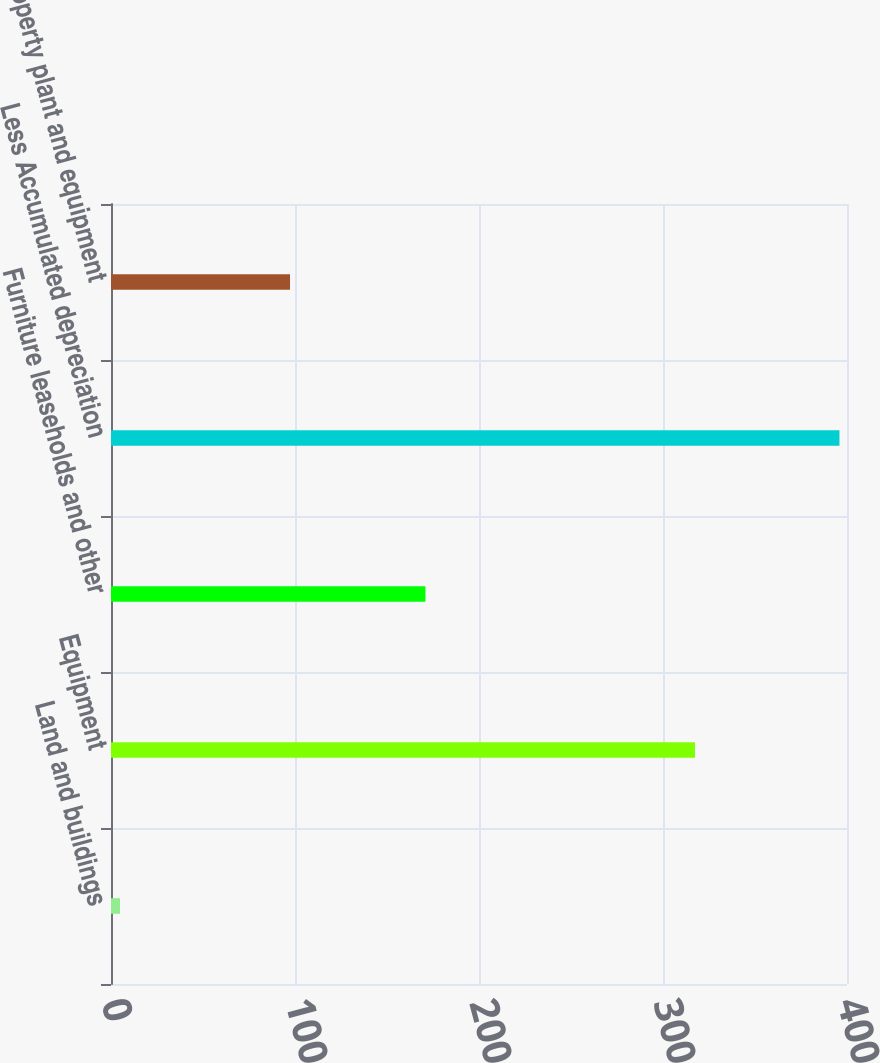Convert chart. <chart><loc_0><loc_0><loc_500><loc_500><bar_chart><fcel>Land and buildings<fcel>Equipment<fcel>Furniture leaseholds and other<fcel>Less Accumulated depreciation<fcel>Property plant and equipment<nl><fcel>4.9<fcel>317.4<fcel>170.9<fcel>395.9<fcel>97.3<nl></chart> 